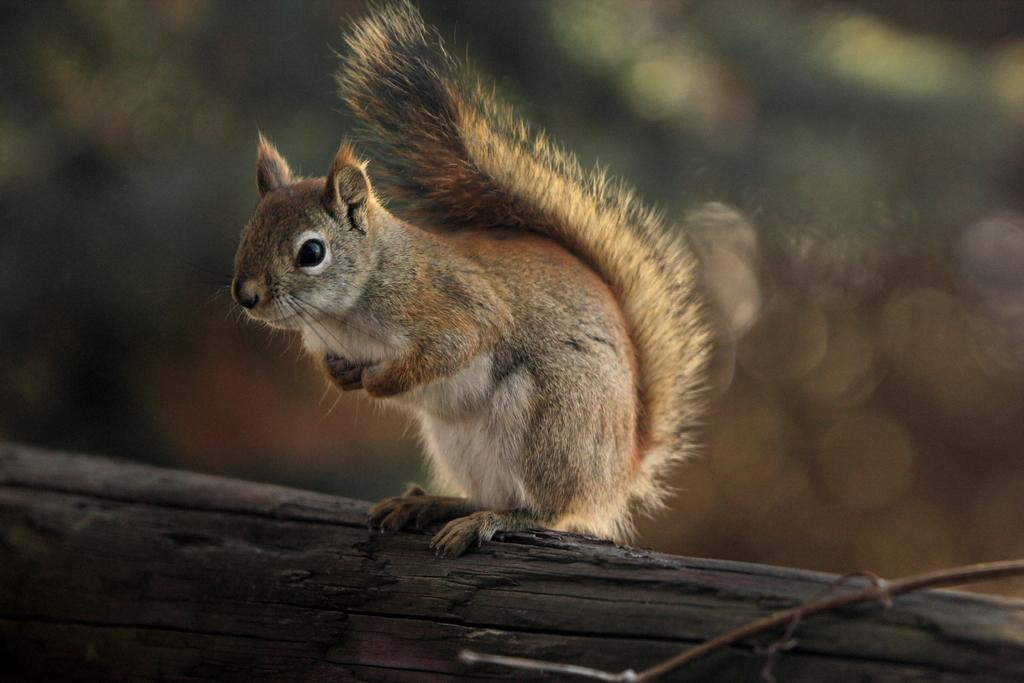What animal can be seen in the image? There is a squirrel in the image. Where is the squirrel located? The squirrel is standing on a branch of a tree. Can you describe the background of the image? The background of the image is blurry. What type of shoe is the squirrel wearing in the image? There is no shoe present in the image, as squirrels do not wear shoes. 